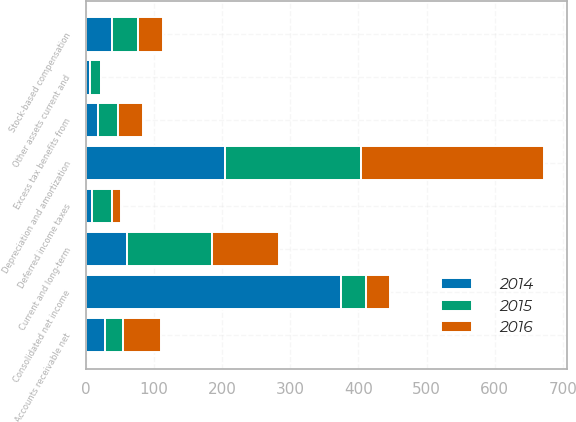Convert chart. <chart><loc_0><loc_0><loc_500><loc_500><stacked_bar_chart><ecel><fcel>Consolidated net income<fcel>Depreciation and amortization<fcel>Stock-based compensation<fcel>Excess tax benefits from<fcel>Deferred income taxes<fcel>Accounts receivable net<fcel>Other assets current and<fcel>Current and long-term<nl><fcel>2016<fcel>36.5<fcel>268.7<fcel>37.1<fcel>35.9<fcel>13<fcel>55.7<fcel>0.3<fcel>99.2<nl><fcel>2015<fcel>36.5<fcel>200<fcel>38.4<fcel>30<fcel>28.7<fcel>26.9<fcel>15.9<fcel>123.8<nl><fcel>2014<fcel>374<fcel>204.2<fcel>38.1<fcel>17.7<fcel>9.6<fcel>27.8<fcel>5.8<fcel>60.8<nl></chart> 